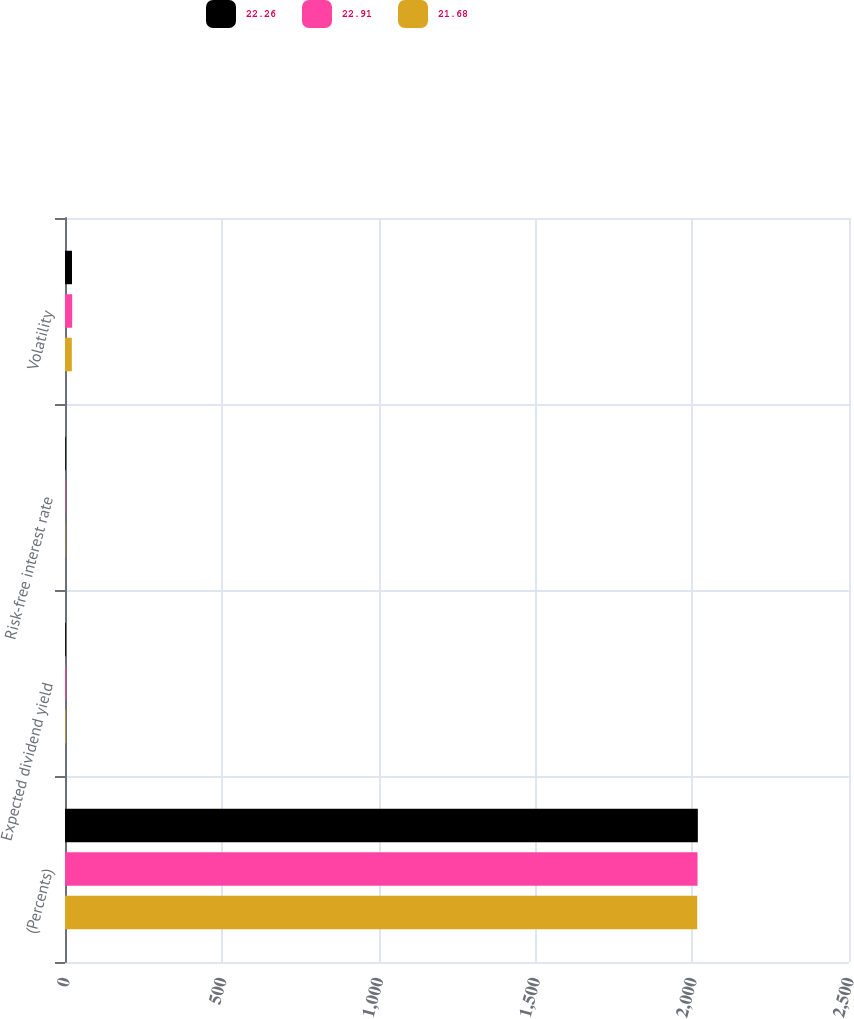Convert chart. <chart><loc_0><loc_0><loc_500><loc_500><stacked_bar_chart><ecel><fcel>(Percents)<fcel>Expected dividend yield<fcel>Risk-free interest rate<fcel>Volatility<nl><fcel>22.26<fcel>2018<fcel>2.5<fcel>2.31<fcel>22.26<nl><fcel>22.91<fcel>2017<fcel>2.5<fcel>1.38<fcel>22.91<nl><fcel>21.68<fcel>2016<fcel>2<fcel>0.92<fcel>21.68<nl></chart> 